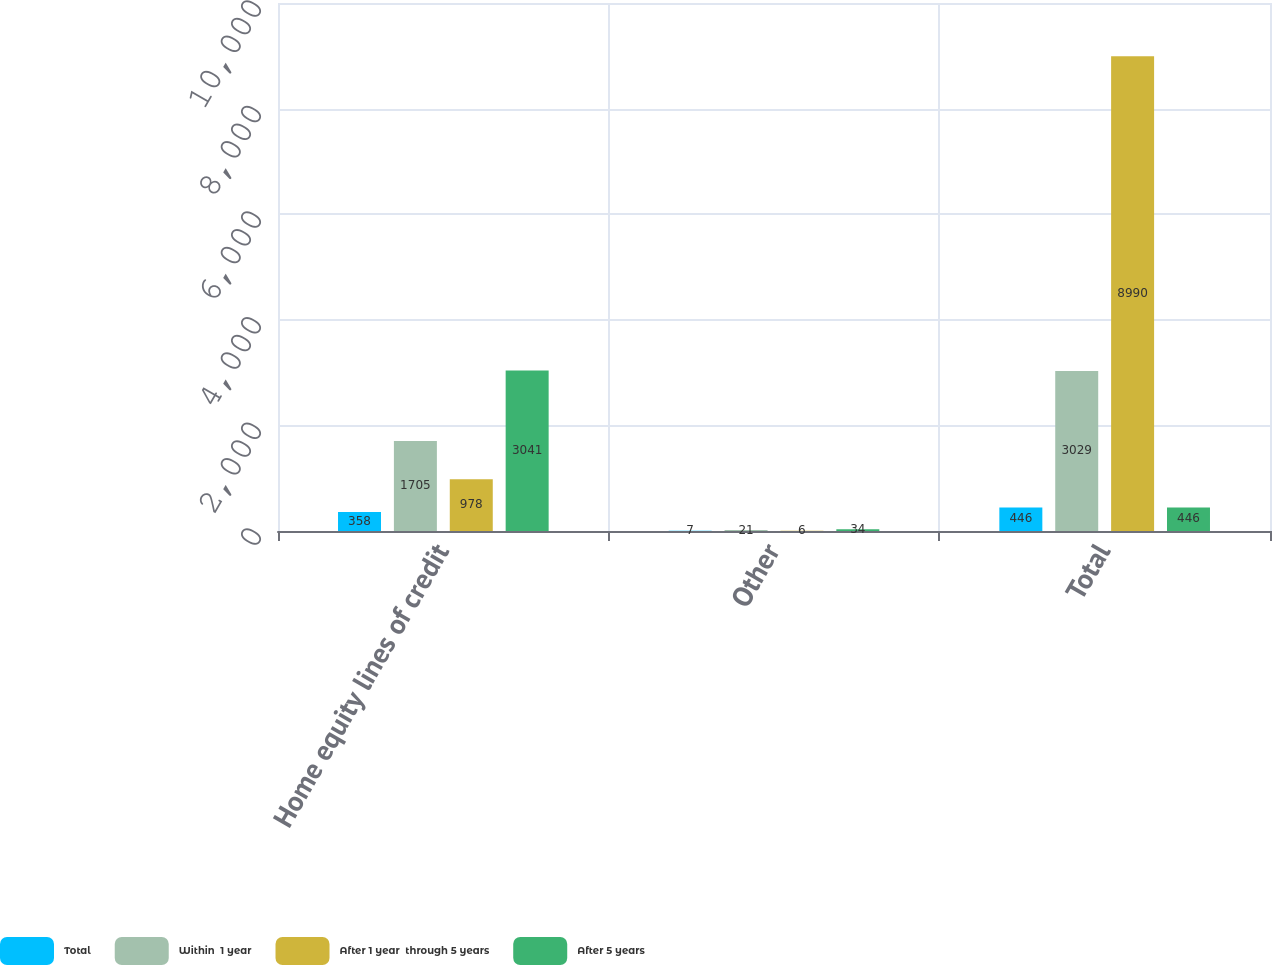Convert chart to OTSL. <chart><loc_0><loc_0><loc_500><loc_500><stacked_bar_chart><ecel><fcel>Home equity lines of credit<fcel>Other<fcel>Total<nl><fcel>Total<fcel>358<fcel>7<fcel>446<nl><fcel>Within  1 year<fcel>1705<fcel>21<fcel>3029<nl><fcel>After 1 year  through 5 years<fcel>978<fcel>6<fcel>8990<nl><fcel>After 5 years<fcel>3041<fcel>34<fcel>446<nl></chart> 